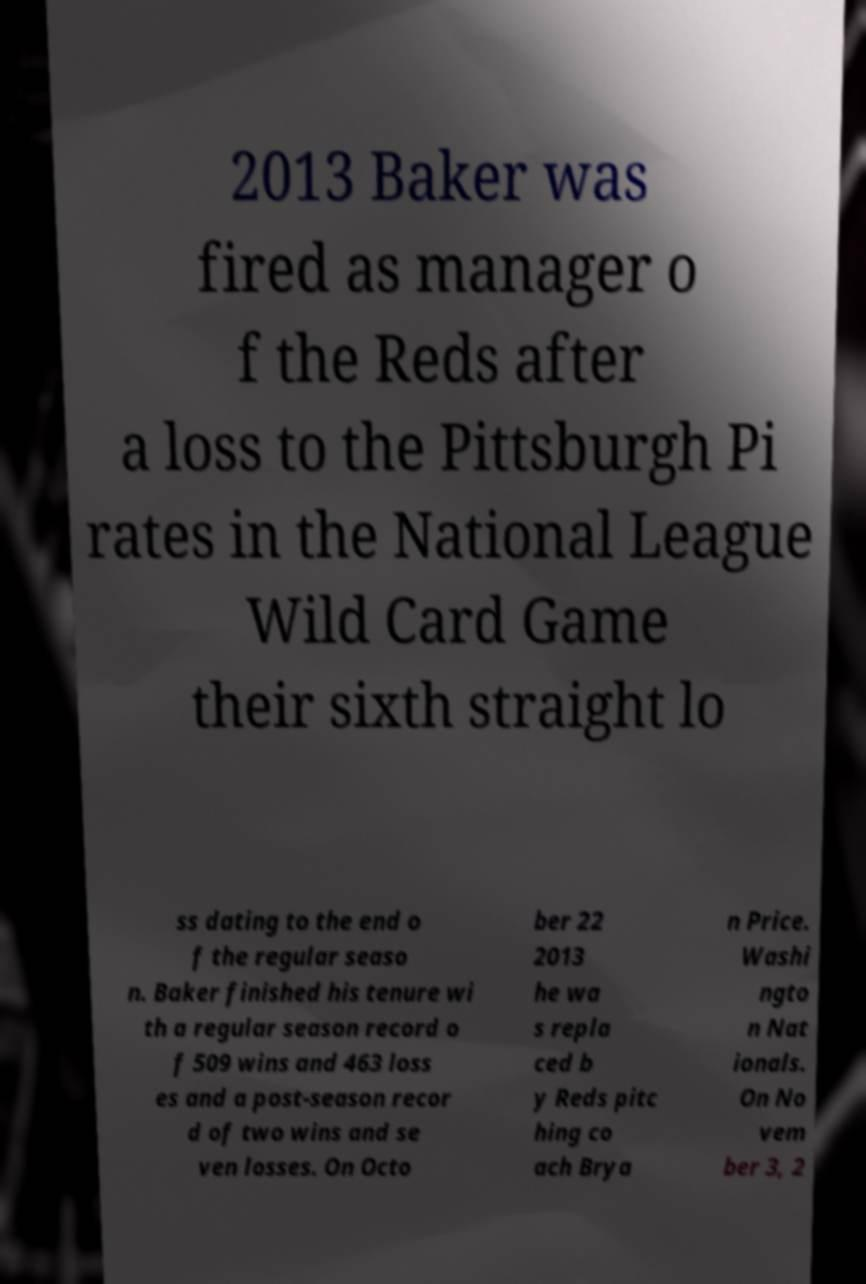Can you accurately transcribe the text from the provided image for me? 2013 Baker was fired as manager o f the Reds after a loss to the Pittsburgh Pi rates in the National League Wild Card Game their sixth straight lo ss dating to the end o f the regular seaso n. Baker finished his tenure wi th a regular season record o f 509 wins and 463 loss es and a post-season recor d of two wins and se ven losses. On Octo ber 22 2013 he wa s repla ced b y Reds pitc hing co ach Brya n Price. Washi ngto n Nat ionals. On No vem ber 3, 2 